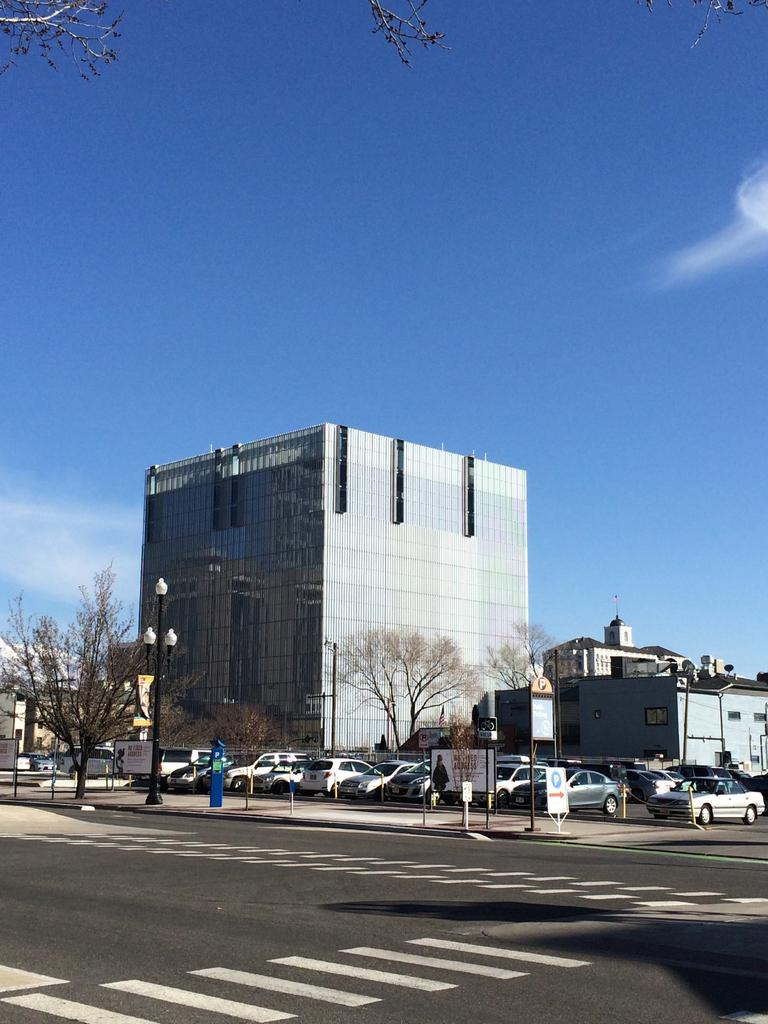What is the main feature of the image? There is a road in the image. What else can be seen on the road? There are cars on the road. What type of natural elements are present in the image? There are trees in the image. Are there any man-made structures visible? Yes, there are poles and buildings in the image. What is visible behind the buildings? The sky is visible behind the buildings. Can you describe the tree branch in the image? A tree branch is present at the top left of the image. What type of crime is being committed in the image? There is no indication of any crime being committed in the image. Can you tell me how many trains are visible in the image? There are no trains present in the image. 